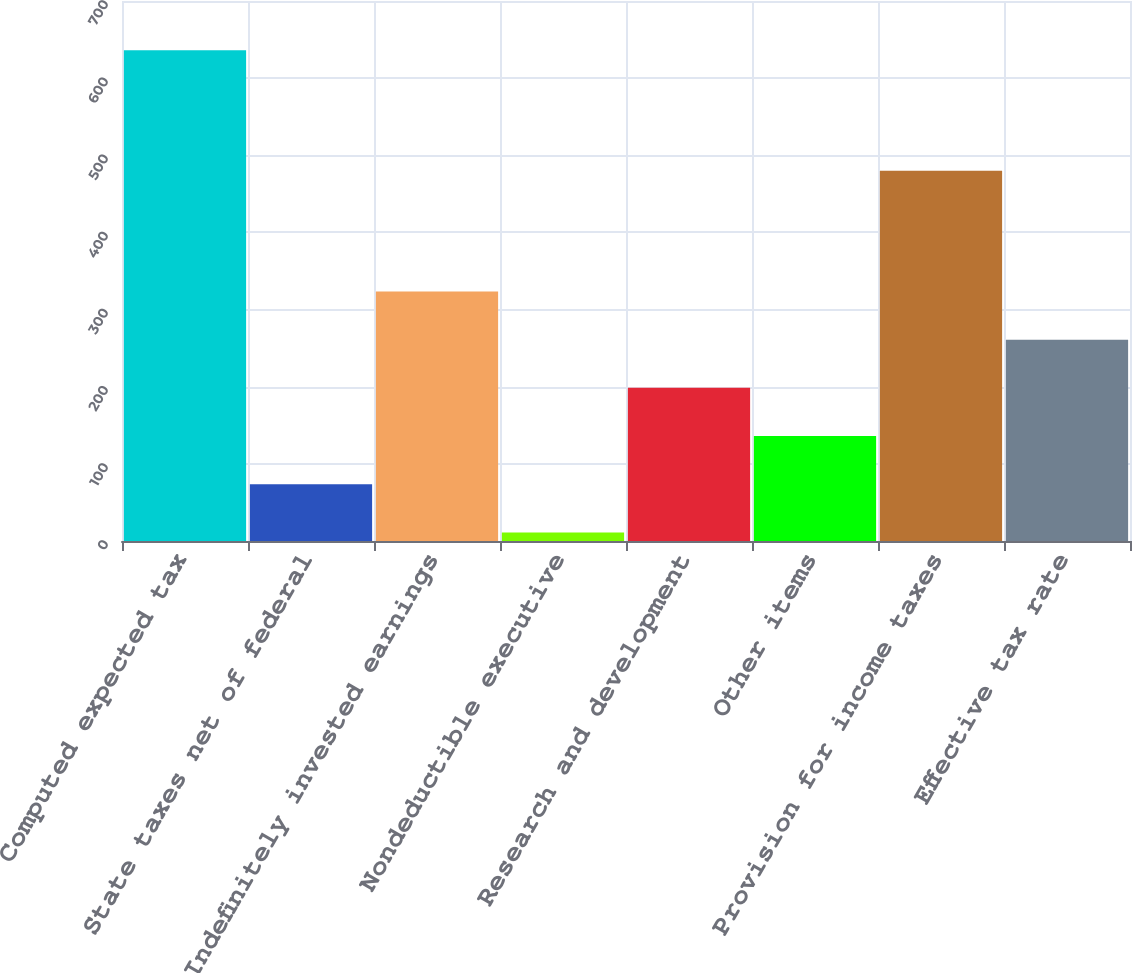Convert chart. <chart><loc_0><loc_0><loc_500><loc_500><bar_chart><fcel>Computed expected tax<fcel>State taxes net of federal<fcel>Indefinitely invested earnings<fcel>Nondeductible executive<fcel>Research and development<fcel>Other items<fcel>Provision for income taxes<fcel>Effective tax rate<nl><fcel>636<fcel>73.5<fcel>323.5<fcel>11<fcel>198.5<fcel>136<fcel>480<fcel>261<nl></chart> 